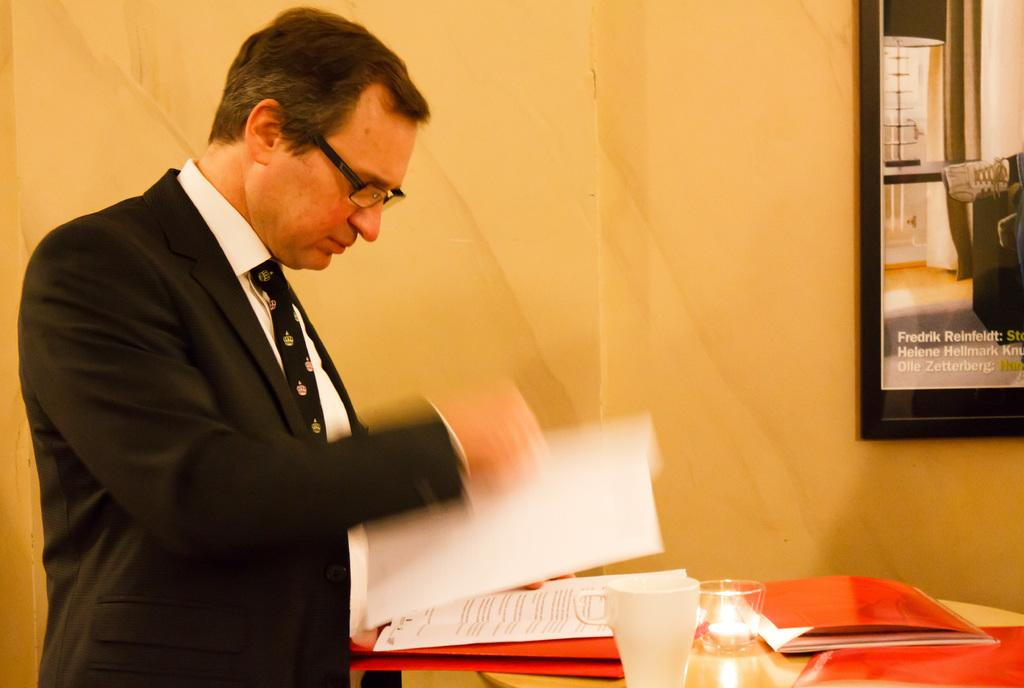What is the person in the image doing? The person is standing in the image and holding a paper in his hand. What is on the table in the image? There are papers, files, and a glass on the table. Can you describe the table in the image? The table is a surface where the papers, files, and glass are placed. What type of flowers are on the person's stomach in the image? There are no flowers or any reference to the person's stomach in the image. 